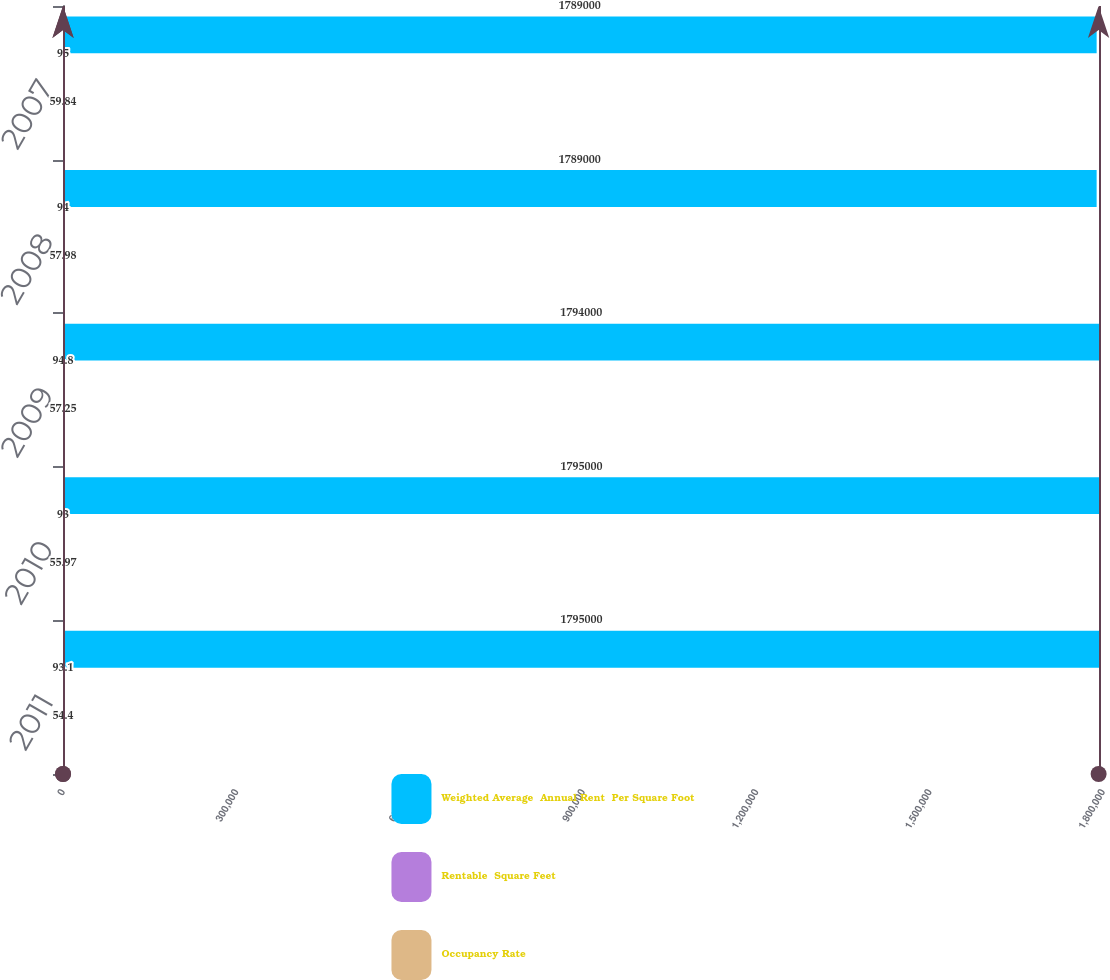<chart> <loc_0><loc_0><loc_500><loc_500><stacked_bar_chart><ecel><fcel>2011<fcel>2010<fcel>2009<fcel>2008<fcel>2007<nl><fcel>Weighted Average  Annual Rent  Per Square Foot<fcel>1.795e+06<fcel>1.795e+06<fcel>1.794e+06<fcel>1.789e+06<fcel>1.789e+06<nl><fcel>Rentable  Square Feet<fcel>93.1<fcel>93<fcel>94.8<fcel>94<fcel>95<nl><fcel>Occupancy Rate<fcel>54.4<fcel>55.97<fcel>57.25<fcel>57.98<fcel>59.84<nl></chart> 